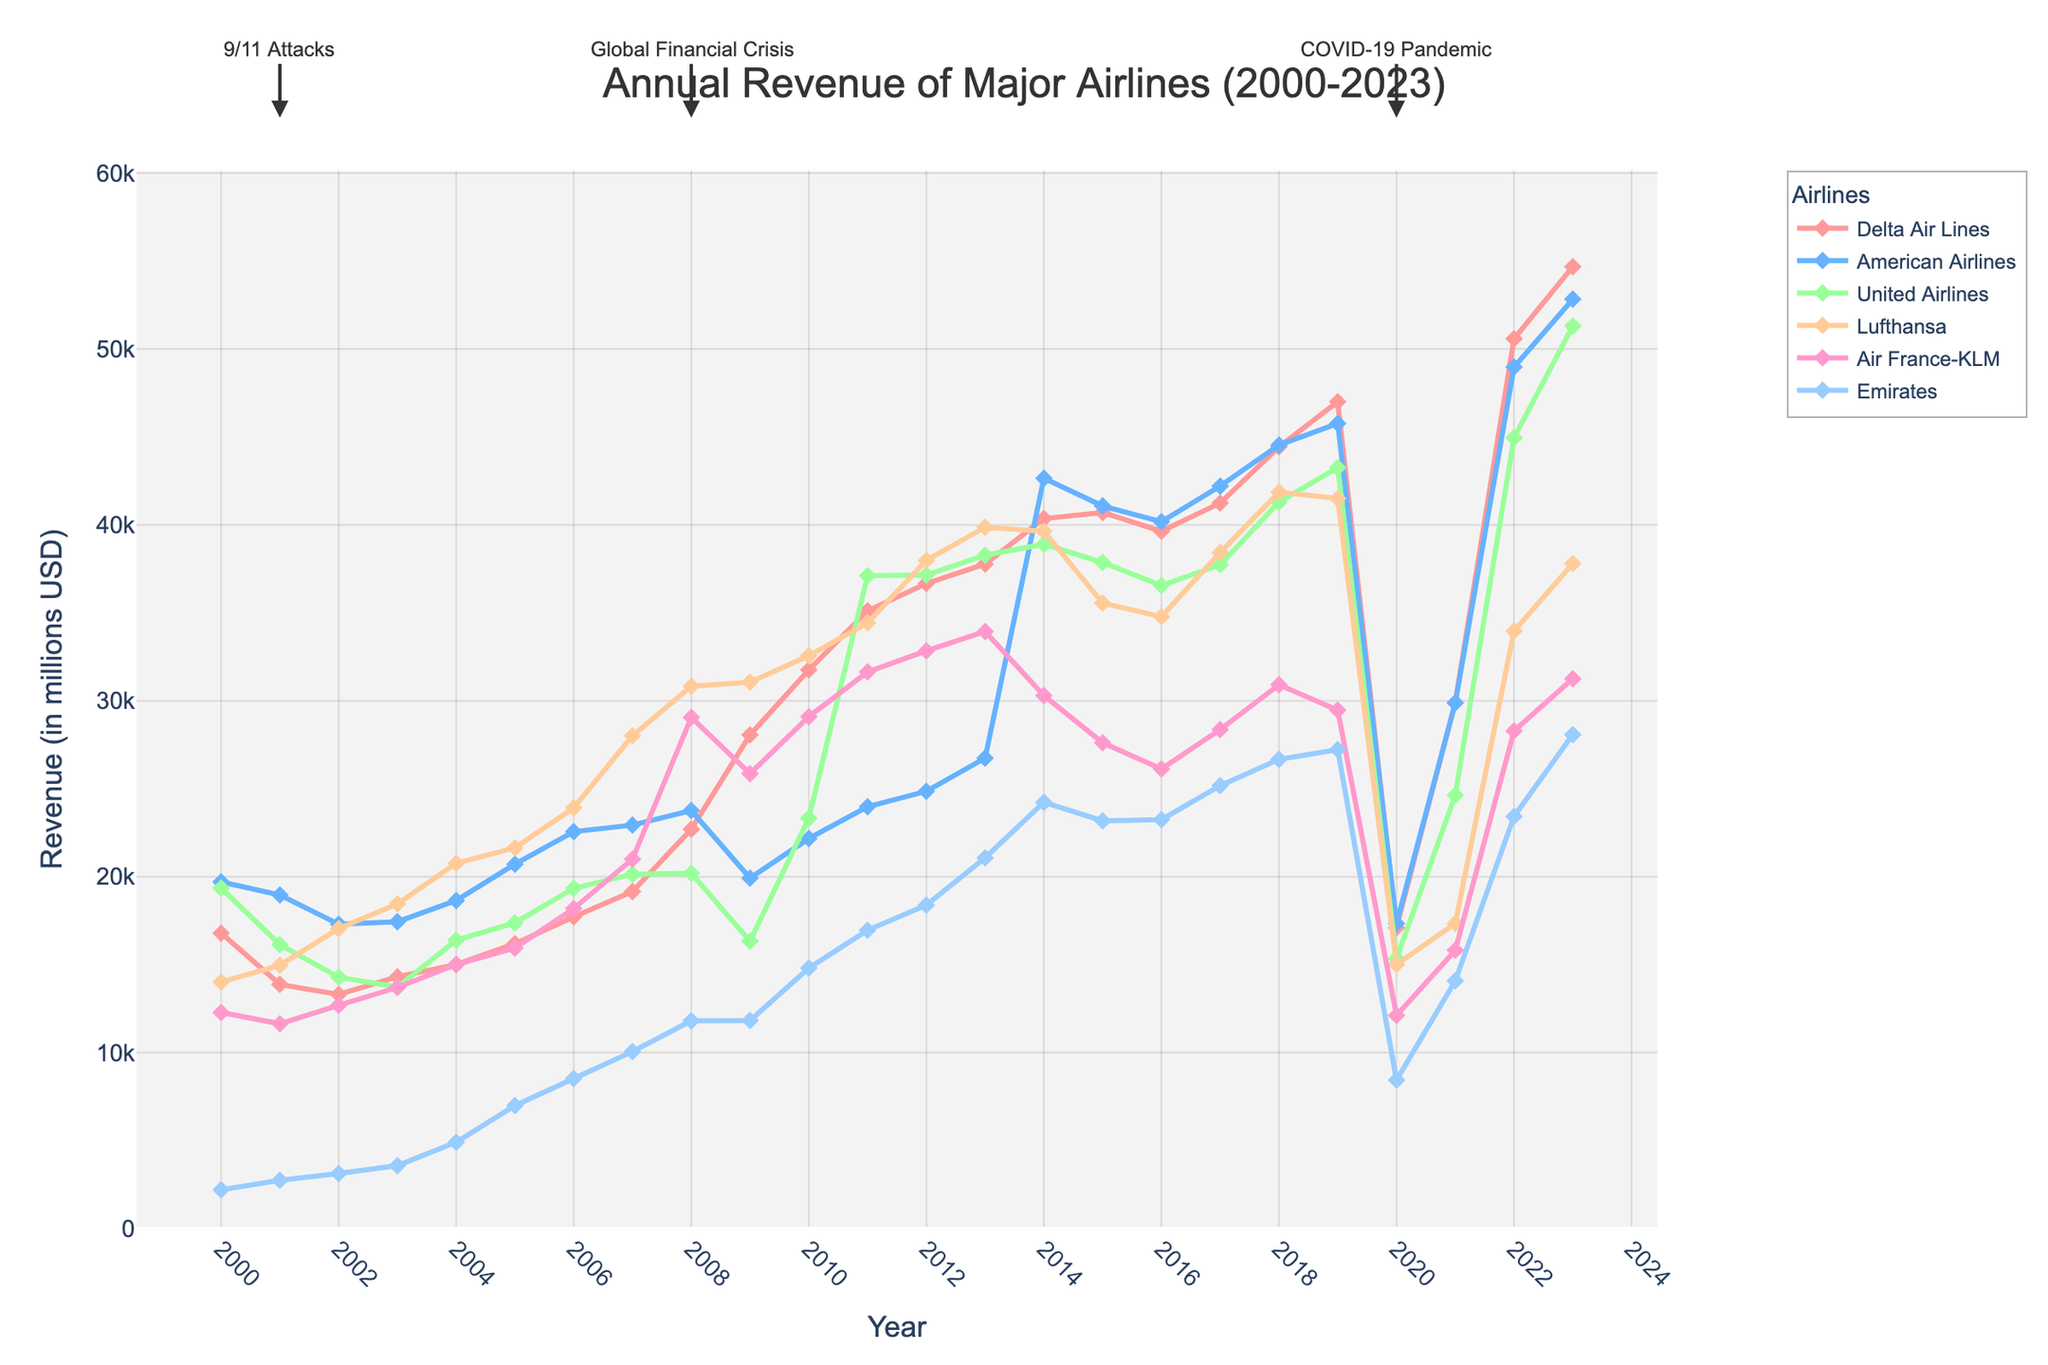Which airline had the highest revenue in 2023? The revenue for each airline in 2023 can be compared. Delta Air Lines had the highest revenue with 54,674 million USD.
Answer: Delta Air Lines How did the revenue of Emirates change from 2000 to 2023? Comparing the Emirates' revenue in 2000 with 2023 shows that it increased from 2,200 million USD to 28,079 million USD.
Answer: Increased Which year did all airlines experience a significant drop in revenue, and why? Observing the trend, there was a visible dip across all airlines in 2020, likely due to the COVID-19 pandemic, marked on the chart.
Answer: 2020 What is the difference in revenue between American Airlines and United Airlines in 2014? In 2014, American Airlines had a revenue of 42,650 million USD while United Airlines had 38,901 million USD. The difference is 42,650 - 38,901.
Answer: 3,749 million USD Compare Delta Air Lines' revenue in 2008 and 2020. Which year was higher and by how much? Delta Air Lines had a revenue of 22,697 million USD in 2008 and 17,095 million USD in 2020. The revenue in 2008 was higher by 22,697 - 17,095.
Answer: 5,602 million USD What trend can you observe for Lufthansa's revenue between 2000 and 2023? Analyzing the line for Lufthansa, initially there is a general increase with fluctuations, a peak in 2012 and 2013 and a significant drop in 2020. However, there's some recovery by 2023.
Answer: Fluctuating with a peak and a significant drop in 2020 How did the global financial crisis in 2008 affect the revenues of American Airlines and Emirates? Comparing the revenue from 2007 to 2008, American Airlines' revenue slightly increased from 22,935 million USD to 23,766 million USD, whereas Emirates' revenue also increased from 10,057 million USD to 11,807 million USD.
Answer: Increased for both What average annual revenue did Air France-KLM achieve from 2010 to 2020? Summing Air France-KLM's revenues from 2010 to 2020 and dividing by 11 years: (29096 + 31643 + 32841 + 33939 + 30303 + 27614 + 26127 + 28365 + 30914 + 29467 + 12117) / 11 = 27,560 million USD.
Answer: 27,560 million USD 